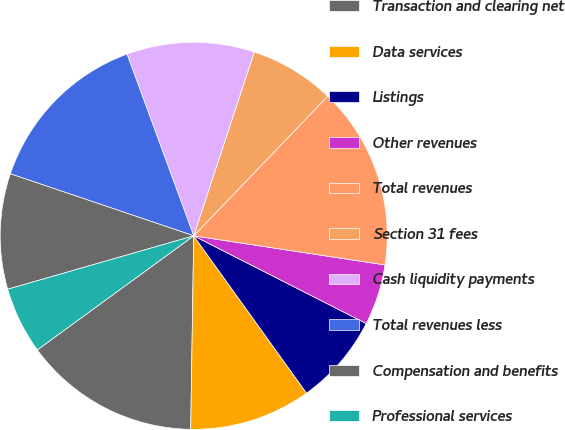<chart> <loc_0><loc_0><loc_500><loc_500><pie_chart><fcel>Transaction and clearing net<fcel>Data services<fcel>Listings<fcel>Other revenues<fcel>Total revenues<fcel>Section 31 fees<fcel>Cash liquidity payments<fcel>Total revenues less<fcel>Compensation and benefits<fcel>Professional services<nl><fcel>14.72%<fcel>10.15%<fcel>7.61%<fcel>5.08%<fcel>15.23%<fcel>7.11%<fcel>10.66%<fcel>14.21%<fcel>9.64%<fcel>5.58%<nl></chart> 